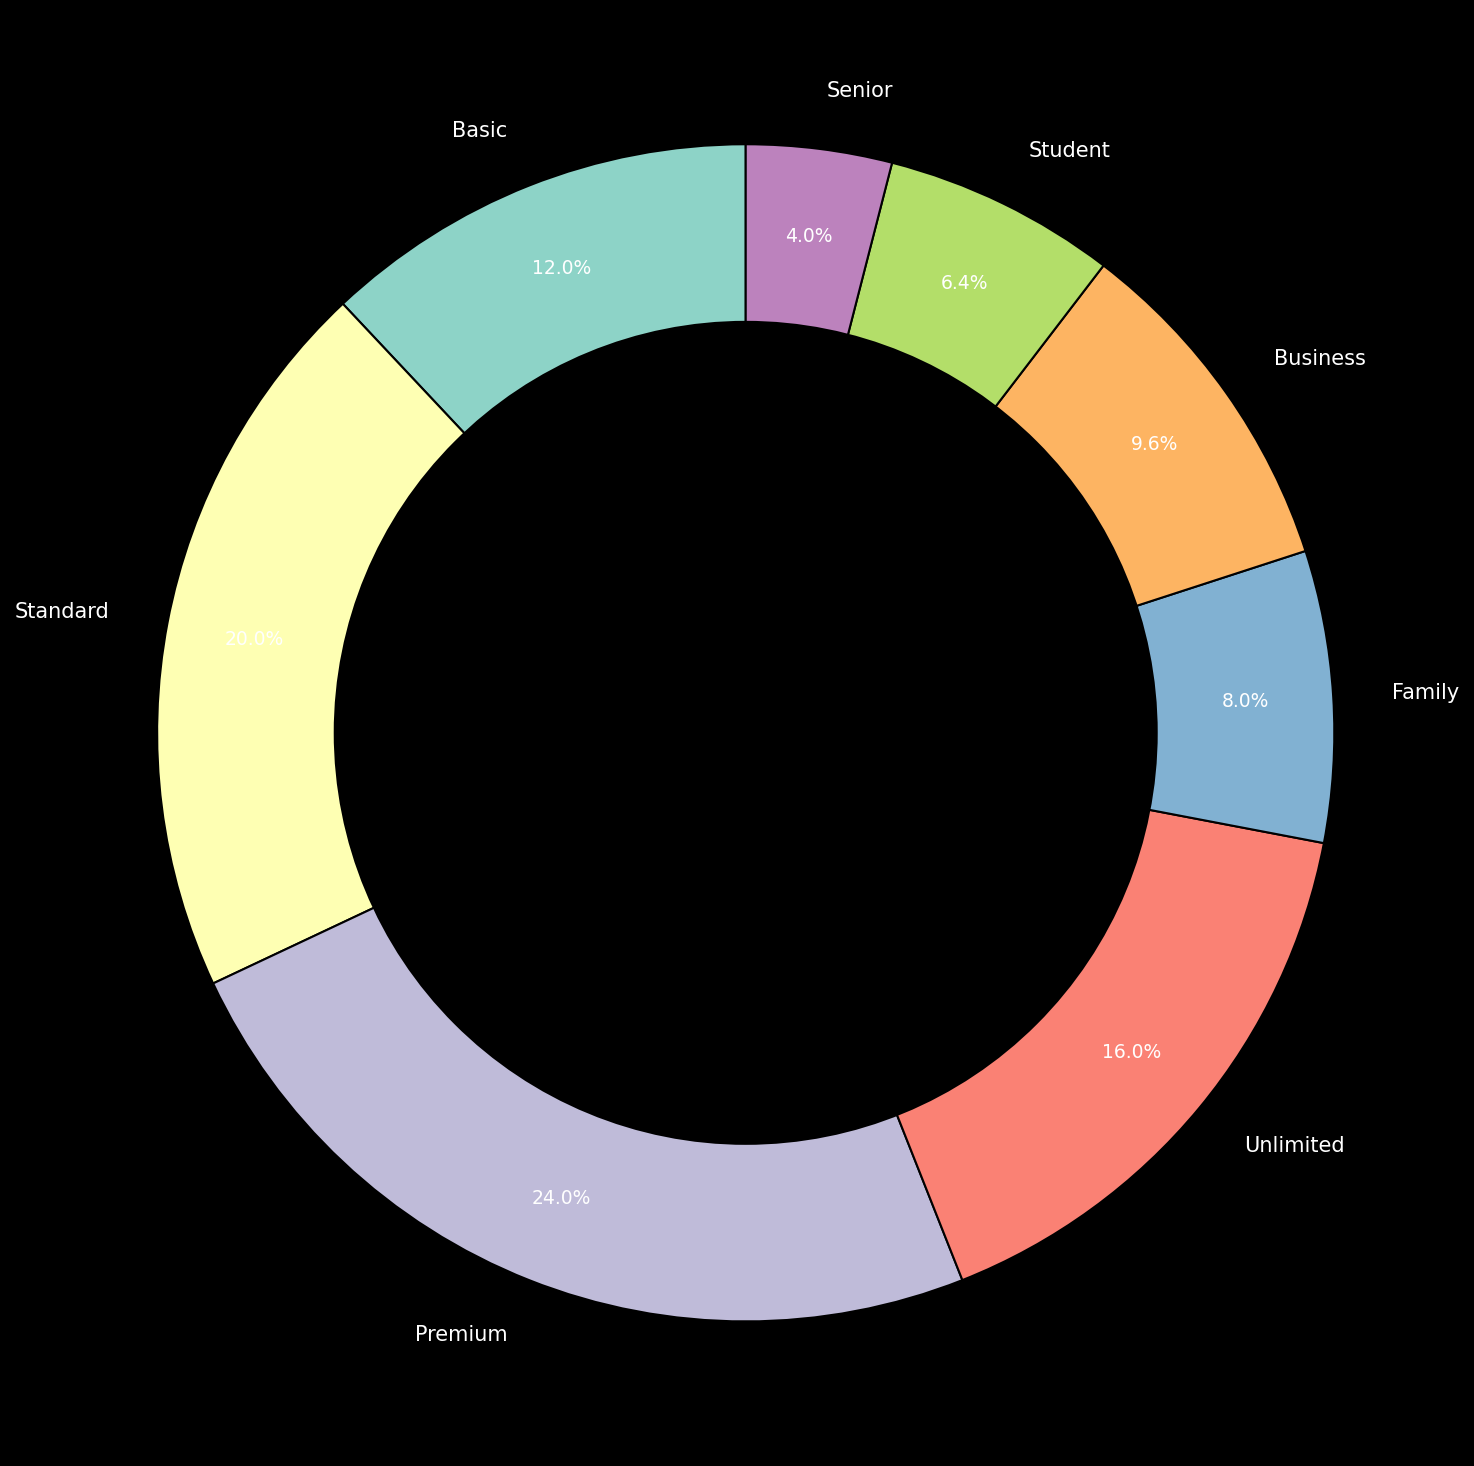Which data plan has the highest percentage of users? The Premium plan has the highest percentage of users. This is evident by the number next to the label for Premium (30%), which is larger than the percentages next to any other plan labels.
Answer: Premium Which two plans together make up the smallest percentage of users? The two plans with the smallest percentages are Senior (5%) and Student (8%). Adding them up, we get 5% + 8% = 13%, which is lower than any other combination of plans.
Answer: Senior and Student Is there a plan that has twice as many users as another? If so, which ones? The Standard plan has 25% of users, while the Business plan has 12% of users. When we round off, 12% * 2 is approximately 24%, which is close to Standard's 25%, making Standard almost twice Business. None of the other plans exhibit this relationship.
Answer: Standard and Business Which category has a percentage closest to the average user percentage across all plans? To find the average, sum all percentages: 15+25+30+20+10+12+8+5 = 125%. The average is 125/8 = 15.625%. The Basic plan at 15% is closest to this average.
Answer: Basic What percentage of users are in the top three most popular plans combined? The three most popular plans are Premium (30%), Standard (25%), and Unlimited (20%). Summing these up gives us 30% + 25% + 20% = 75%.
Answer: 75% Between the Basic and Family plans, which one has more users, and by how much? Basic has 15% and Family has 10%. The difference is 15% - 10% = 5%.
Answer: Basic by 5% How many plans have more than 15% but less than 30% of users? Name them. The plans within this range are Standard (25%) and Unlimited (20%), making a total of two plans.
Answer: Two plans: Standard and Unlimited If the Family plan's user percentage doubled, how would it compare to the Business plan? Doubling the Family plan’s percentage: 10% * 2 = 20%. It would equal the percentage of the Unlimited plan and be greater than the Business plan, which is at 12%.
Answer: It would be greater 